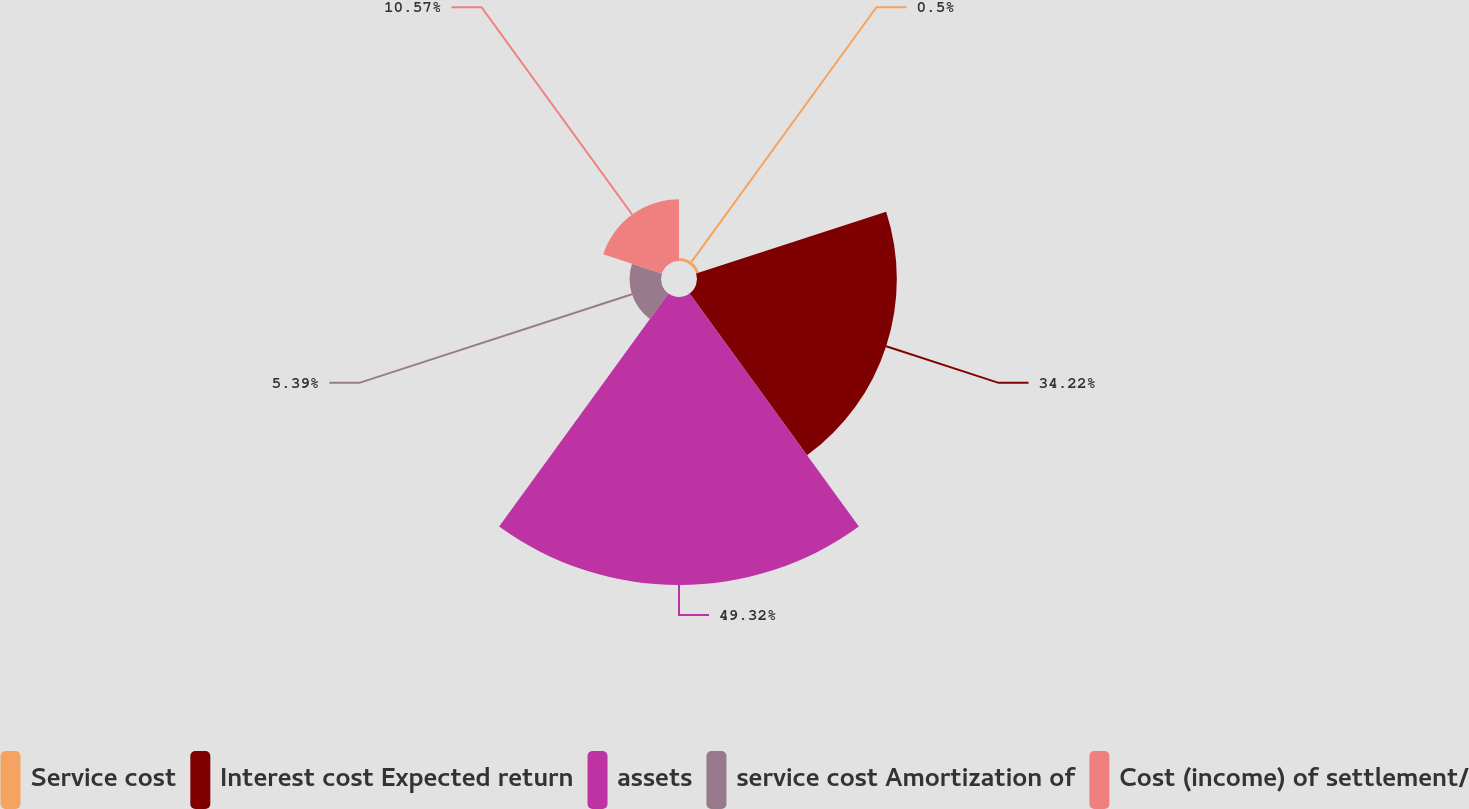<chart> <loc_0><loc_0><loc_500><loc_500><pie_chart><fcel>Service cost<fcel>Interest cost Expected return<fcel>assets<fcel>service cost Amortization of<fcel>Cost (income) of settlement/<nl><fcel>0.5%<fcel>34.22%<fcel>49.32%<fcel>5.39%<fcel>10.57%<nl></chart> 